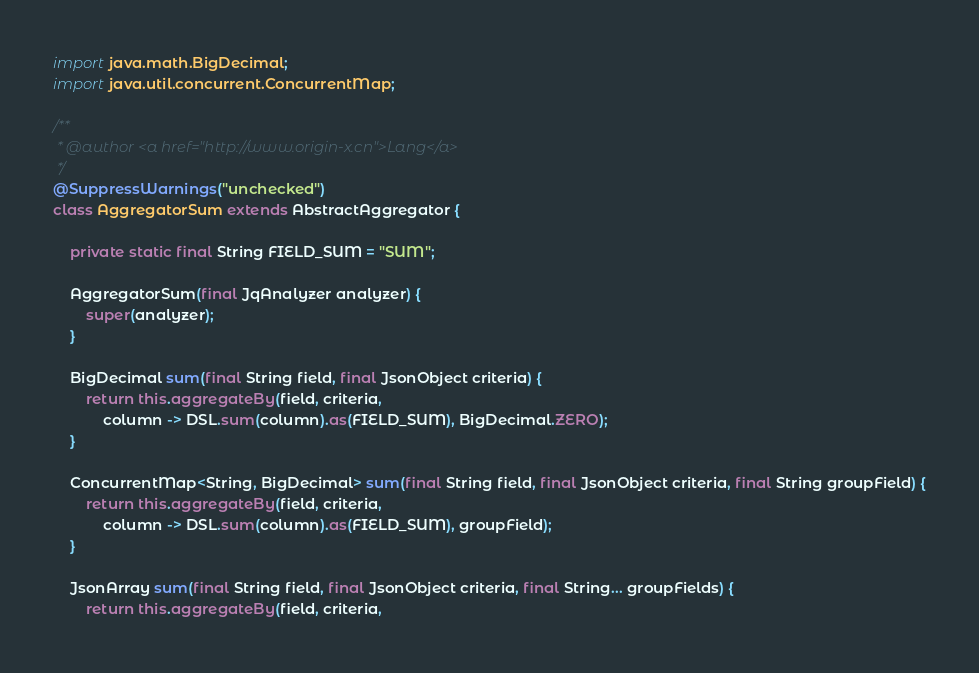<code> <loc_0><loc_0><loc_500><loc_500><_Java_>
import java.math.BigDecimal;
import java.util.concurrent.ConcurrentMap;

/**
 * @author <a href="http://www.origin-x.cn">Lang</a>
 */
@SuppressWarnings("unchecked")
class AggregatorSum extends AbstractAggregator {

    private static final String FIELD_SUM = "SUM";

    AggregatorSum(final JqAnalyzer analyzer) {
        super(analyzer);
    }

    BigDecimal sum(final String field, final JsonObject criteria) {
        return this.aggregateBy(field, criteria,
            column -> DSL.sum(column).as(FIELD_SUM), BigDecimal.ZERO);
    }

    ConcurrentMap<String, BigDecimal> sum(final String field, final JsonObject criteria, final String groupField) {
        return this.aggregateBy(field, criteria,
            column -> DSL.sum(column).as(FIELD_SUM), groupField);
    }

    JsonArray sum(final String field, final JsonObject criteria, final String... groupFields) {
        return this.aggregateBy(field, criteria,</code> 